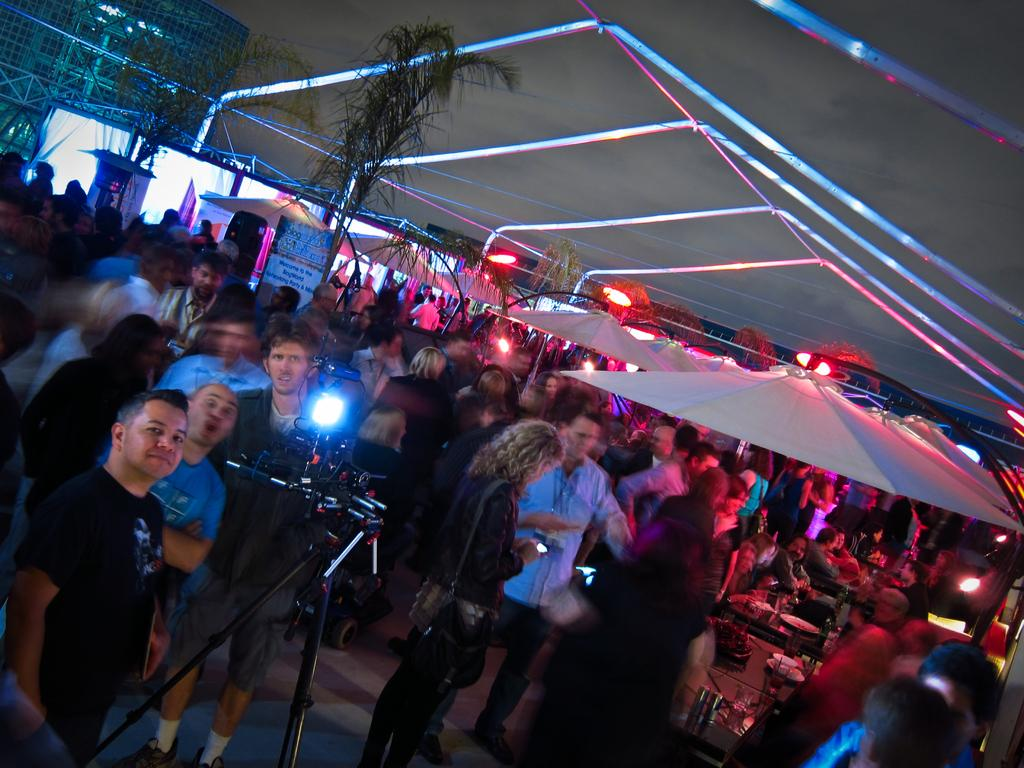What is happening in the image involving the group of people? There is a group of people standing in the image. What object is visible that is typically used for capturing images? There is a camera visible in the image. What color are the umbrellas in the image? There are white-colored umbrellas in the image. What type of vegetation can be seen in the image? There are green-colored trees in the image. What type of animal is sitting on the scarecrow in the image? There is no scarecrow or animal present in the image. What is the texture of the trees in the image? The provided facts do not mention the texture of the trees, only their color. 